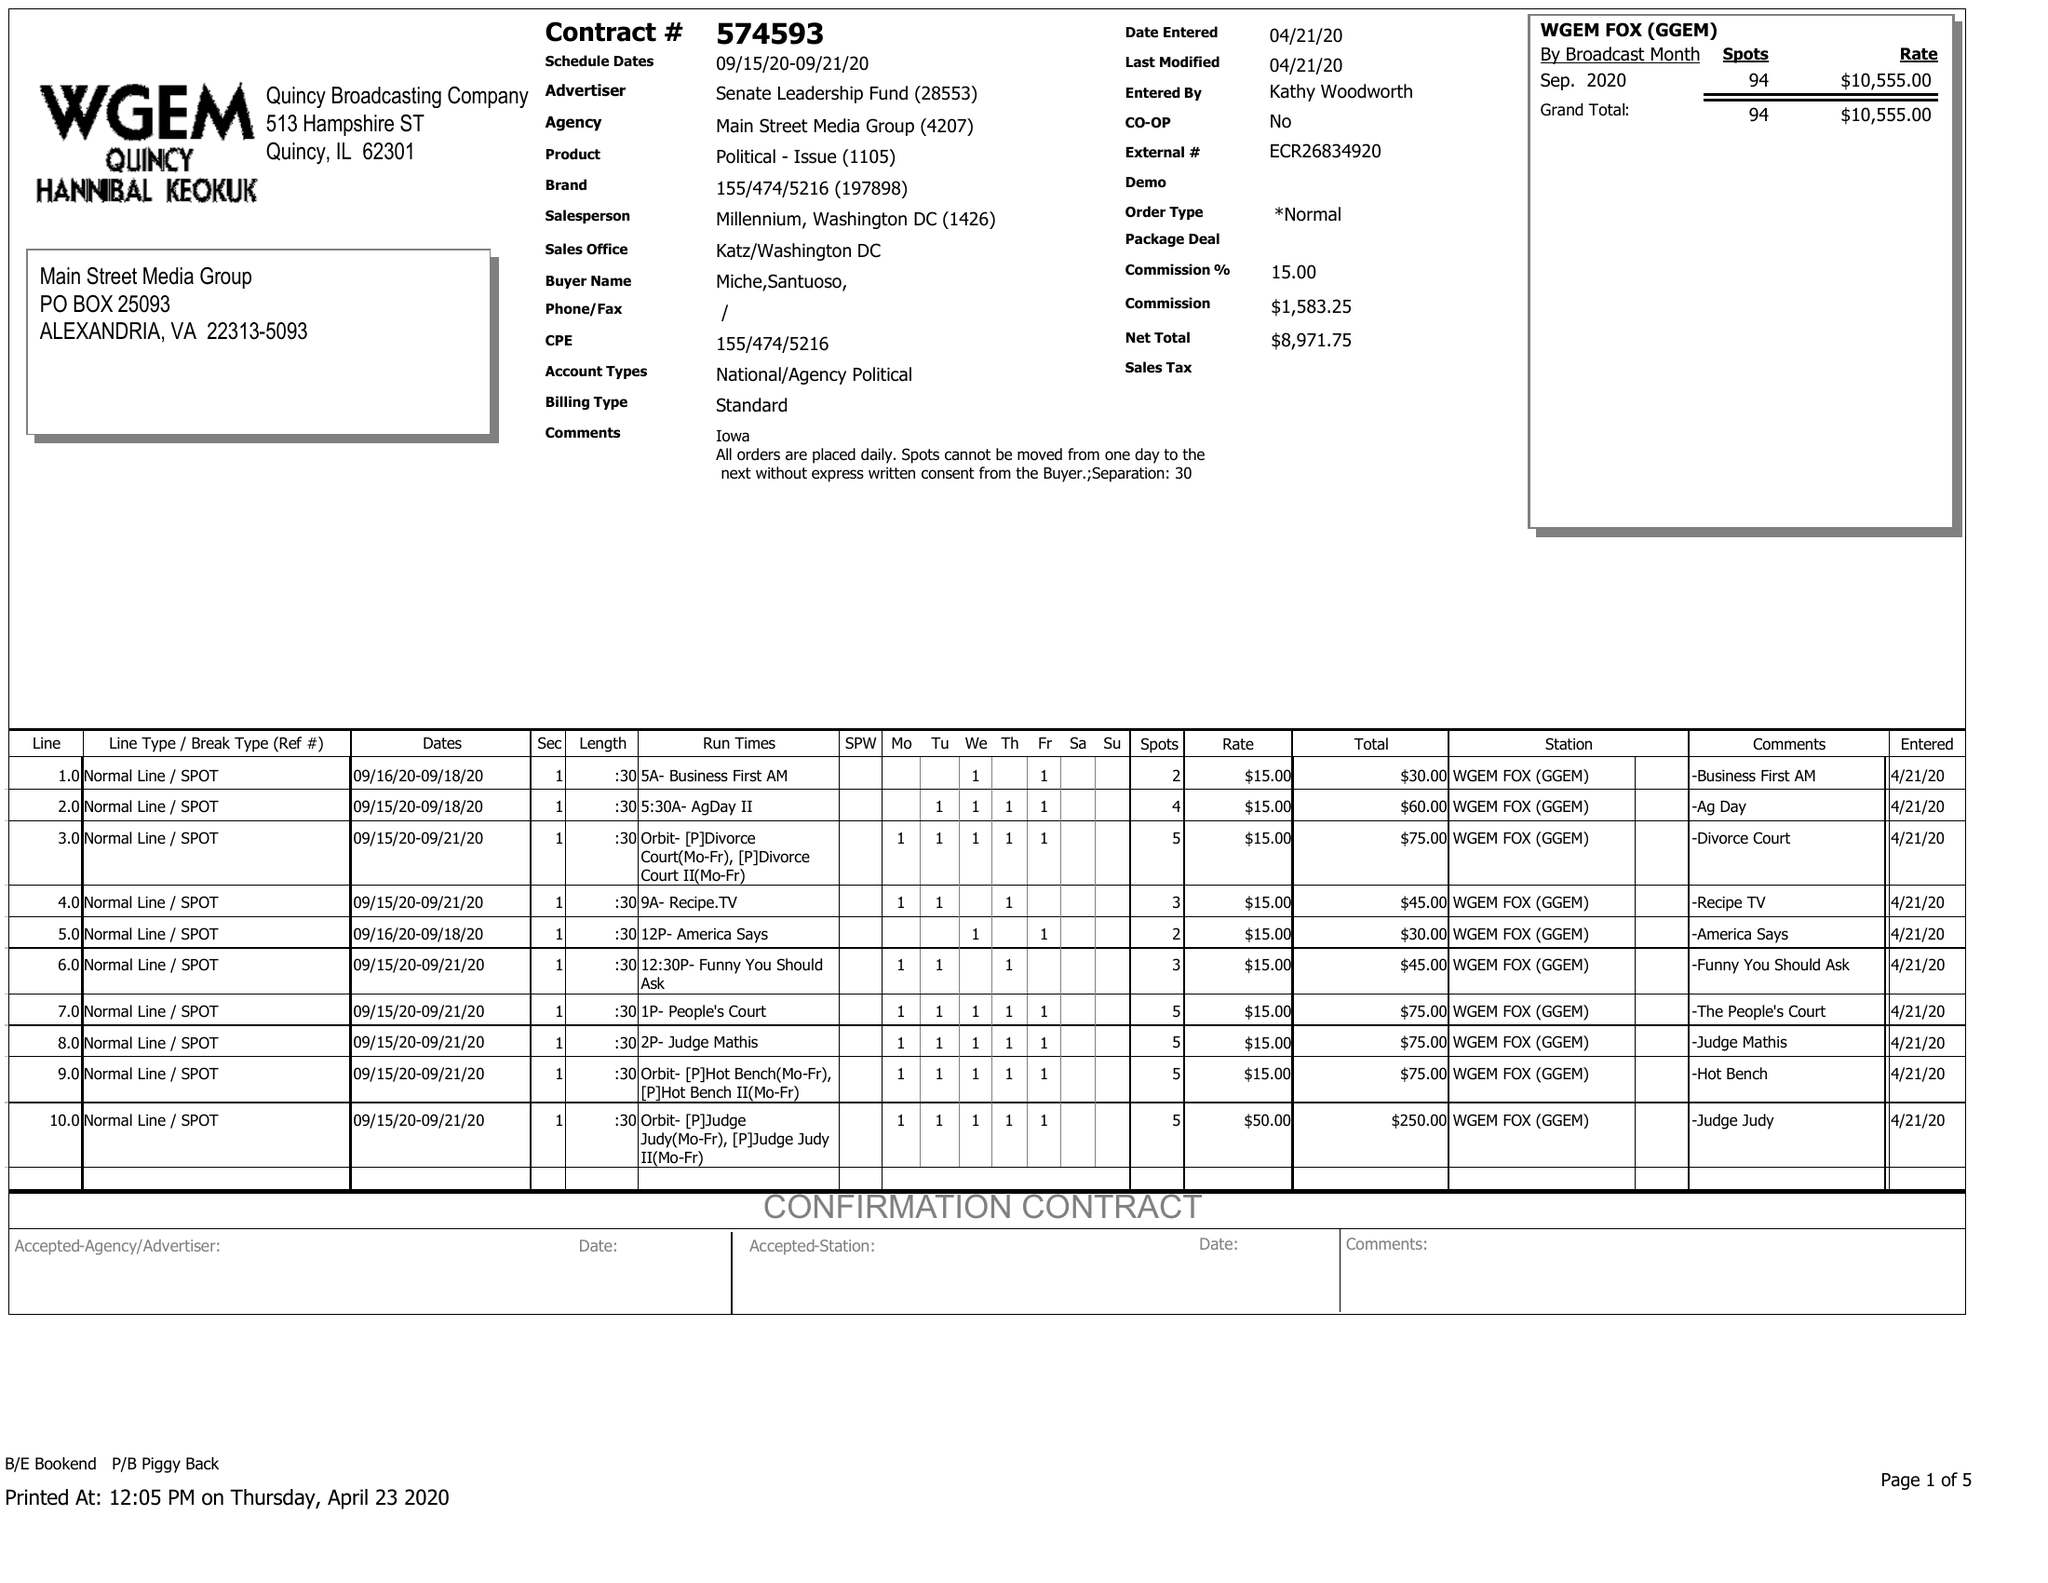What is the value for the gross_amount?
Answer the question using a single word or phrase. 10555.00 